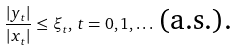Convert formula to latex. <formula><loc_0><loc_0><loc_500><loc_500>\frac { | y _ { t } | } { | x _ { t } | } \leq \xi _ { t } , \, t = 0 , 1 , \dots \, \text {(a.s.).}</formula> 